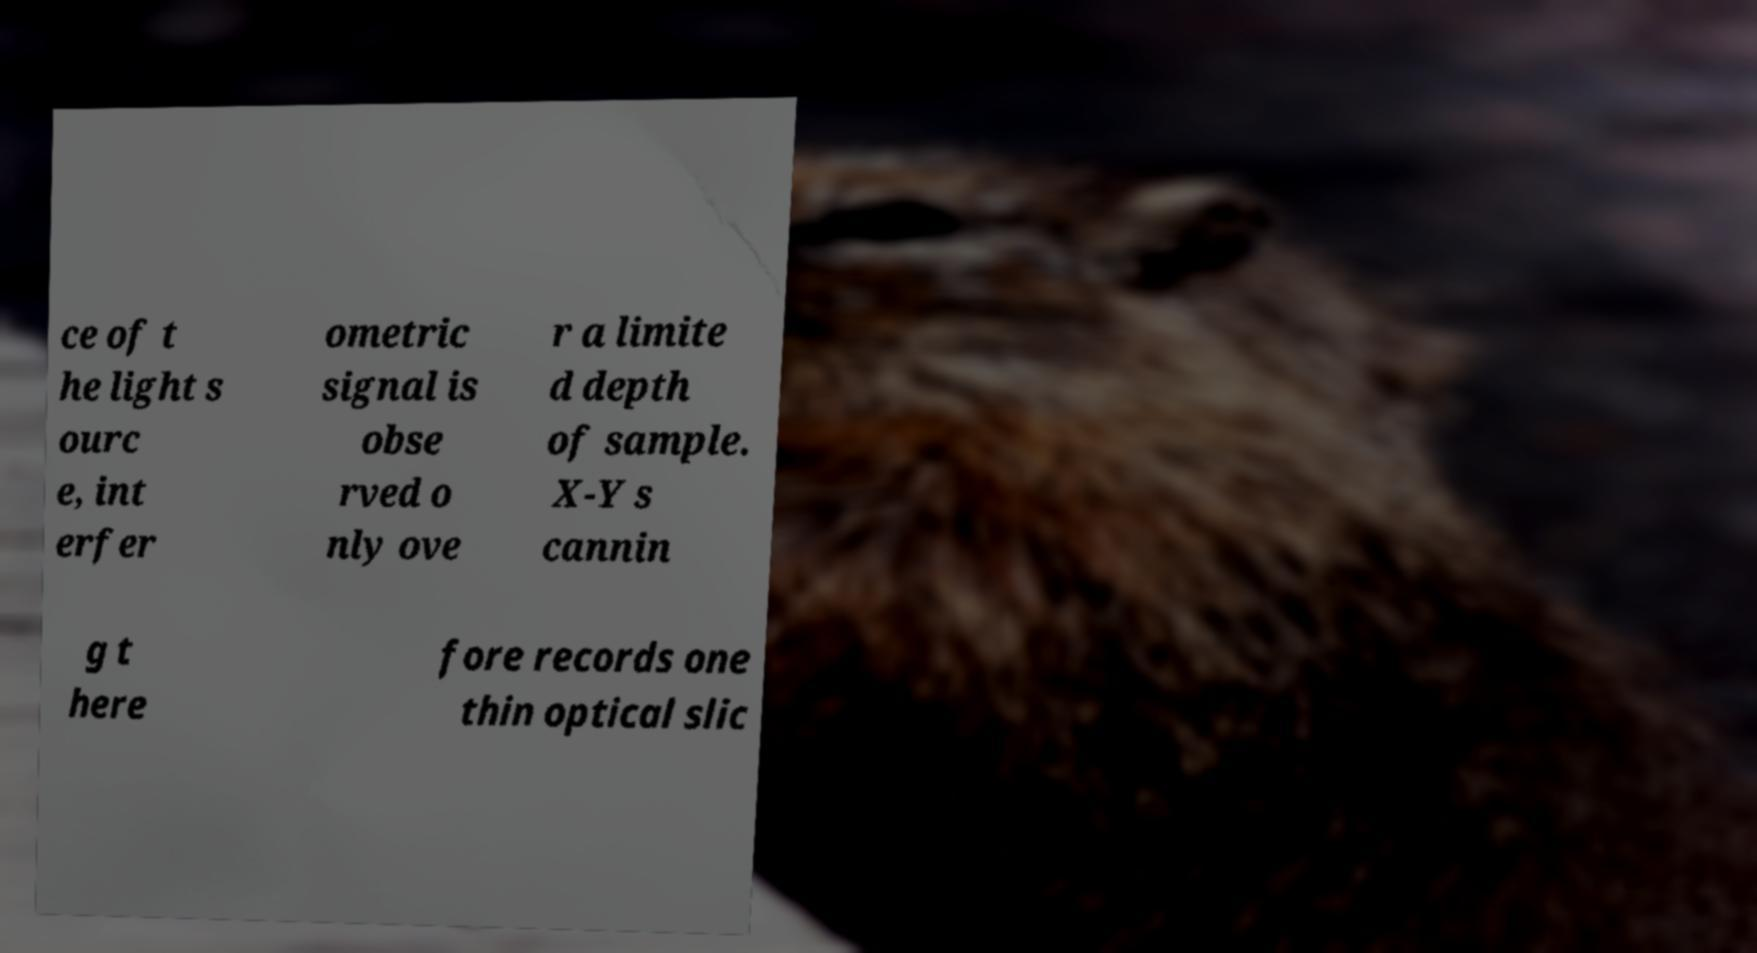What messages or text are displayed in this image? I need them in a readable, typed format. ce of t he light s ourc e, int erfer ometric signal is obse rved o nly ove r a limite d depth of sample. X-Y s cannin g t here fore records one thin optical slic 